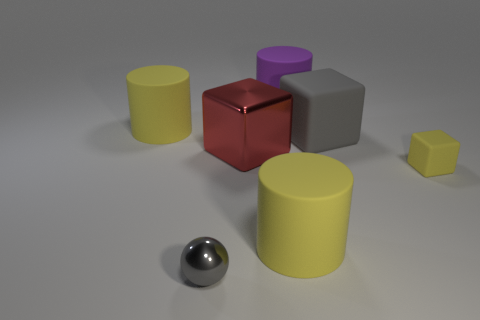Subtract all yellow cubes. How many cubes are left? 2 Add 1 small yellow things. How many objects exist? 8 Subtract 1 cubes. How many cubes are left? 2 Subtract all yellow cylinders. How many cylinders are left? 1 Subtract all blocks. How many objects are left? 4 Add 7 big blue rubber cylinders. How many big blue rubber cylinders exist? 7 Subtract 0 brown blocks. How many objects are left? 7 Subtract all green cylinders. Subtract all purple cubes. How many cylinders are left? 3 Subtract all red cylinders. How many green spheres are left? 0 Subtract all shiny balls. Subtract all small objects. How many objects are left? 4 